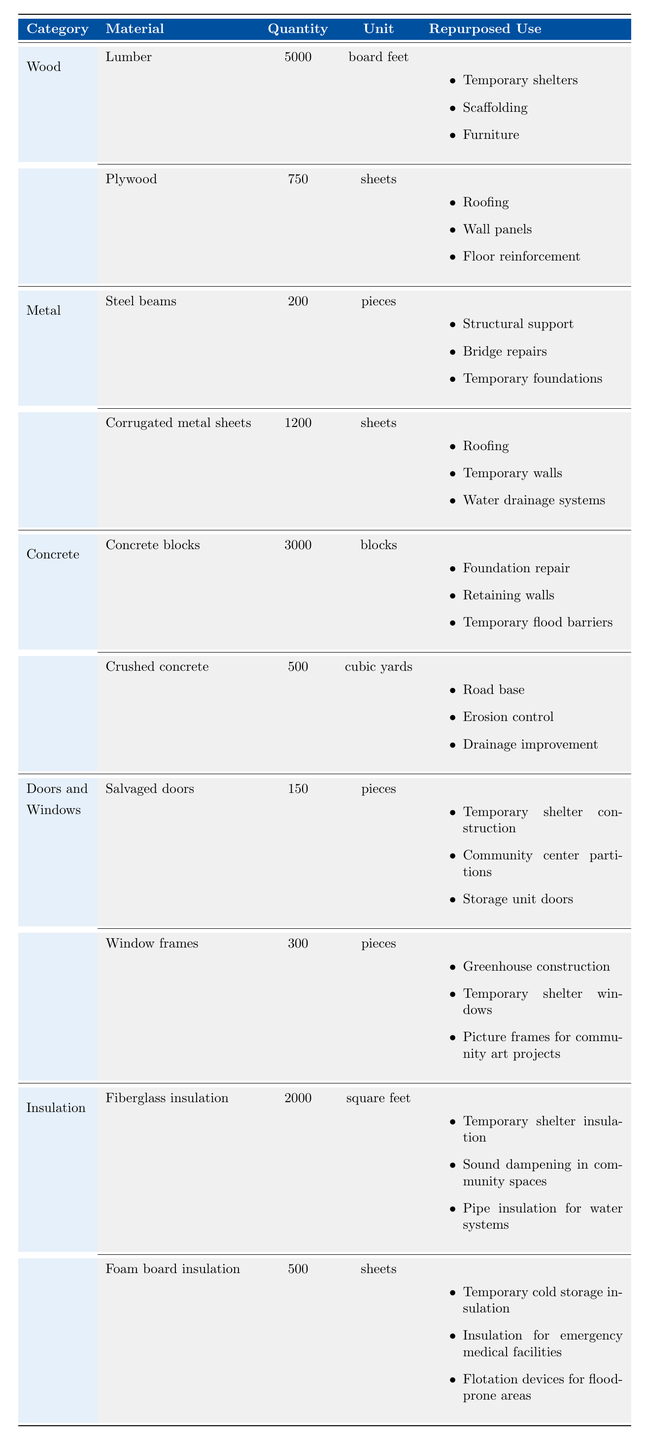What is the total quantity of lumber available for repurposing? The table shows that there are 5000 board feet of lumber listed under the Wood category.
Answer: 5000 board feet How many pieces of window frames are available? Referring to the Doors and Windows category, there are 300 pieces of window frames listed.
Answer: 300 pieces Which material has the highest quantity? By comparing quantities, lumber has 5000 board feet, which is greater than any other material listed, making it the highest.
Answer: Lumber Is crushed concrete used for erosion control? Yes, the table indicates that one of the repurposed uses for crushed concrete is erosion control.
Answer: Yes How many different repurposed uses are there for plywood? Plywood has three repurposed uses listed: roofing, wall panels, and floor reinforcement.
Answer: 3 What is the total quantity of concrete materials available? There are 3000 concrete blocks and 500 cubic yards of crushed concrete. Their total quantity is 3000 + 500 = 3500.
Answer: 3500 Are salvaged doors used in the construction of temporary shelters? Yes, the repurposed uses for salvaged doors include temporary shelter construction.
Answer: Yes What is the combined quantity of insulation materials? There are 2000 square feet of fiberglass insulation and 500 sheets of foam board insulation, which gives a total of 2000 + 500 = 2500.
Answer: 2500 How many different types of insulation are listed? The table shows two types of insulation materials: fiberglass insulation and foam board insulation.
Answer: 2 If we repurpose all the concrete blocks and steel beams for foundation repairs, what is their total quantity? The total quantity is 3000 concrete blocks + 200 steel beams = 3200 total for foundation repairs.
Answer: 3200 